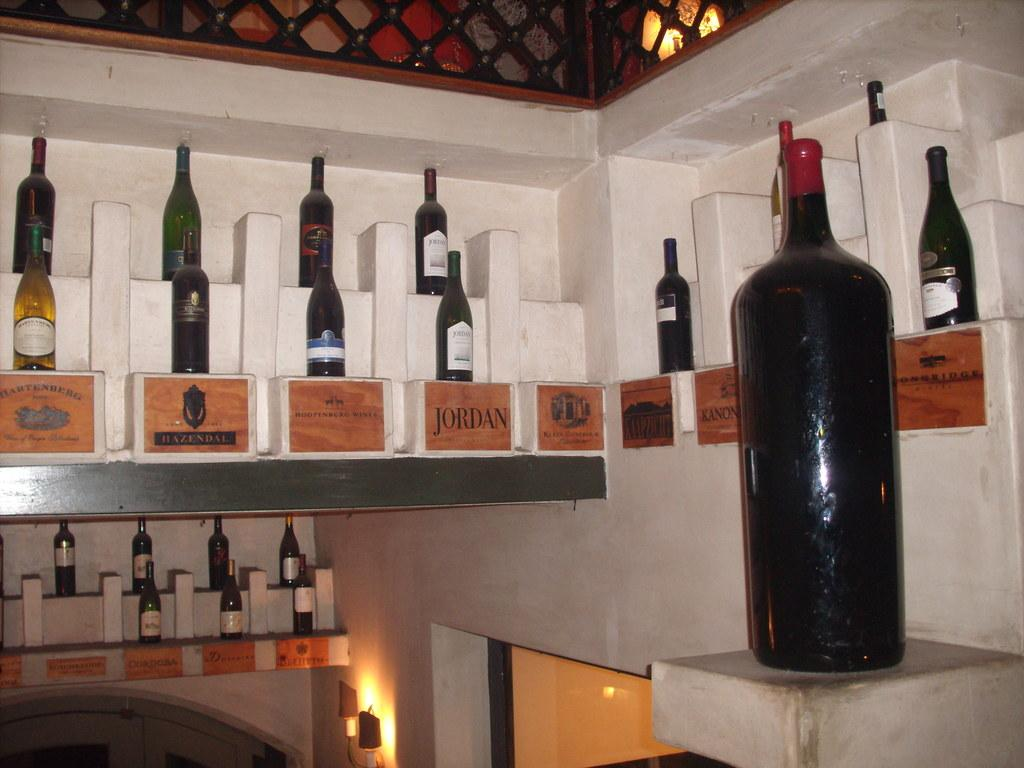<image>
Offer a succinct explanation of the picture presented. Several wine bottles are shown with a wooden sign below denoting the brand such as "Hoopenburg Wines." 